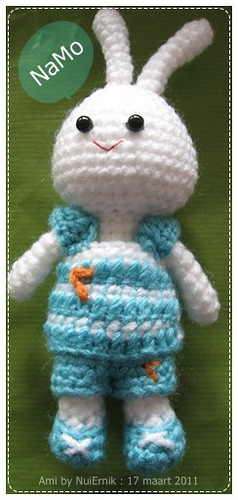<image>
Is the bunny under the fabric? No. The bunny is not positioned under the fabric. The vertical relationship between these objects is different. 